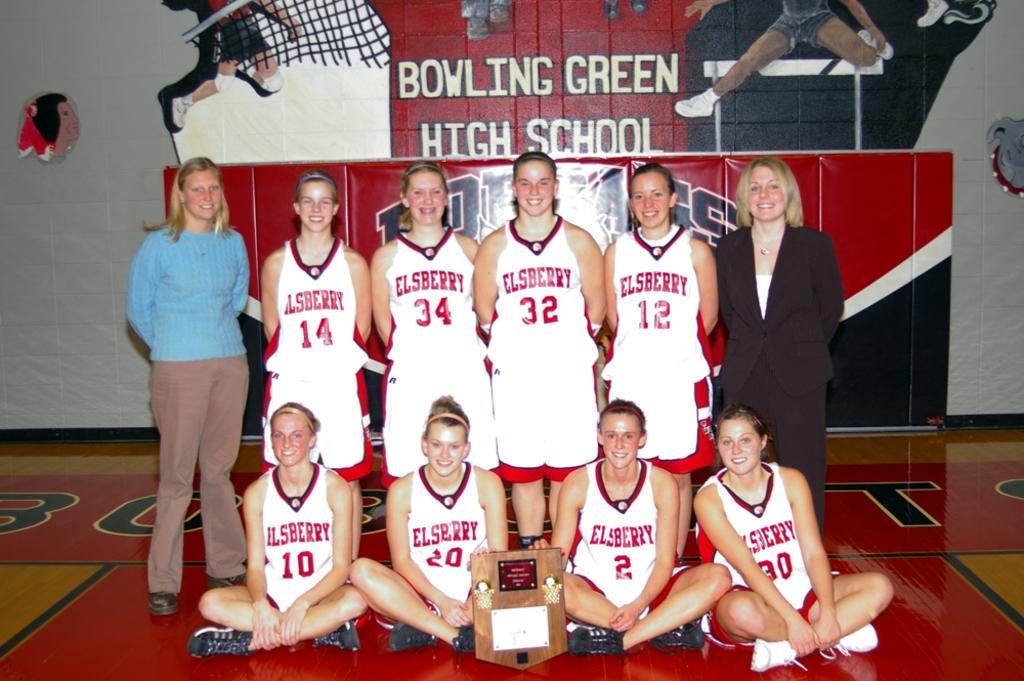What is this team's name?
Give a very brief answer. Elsberry. 